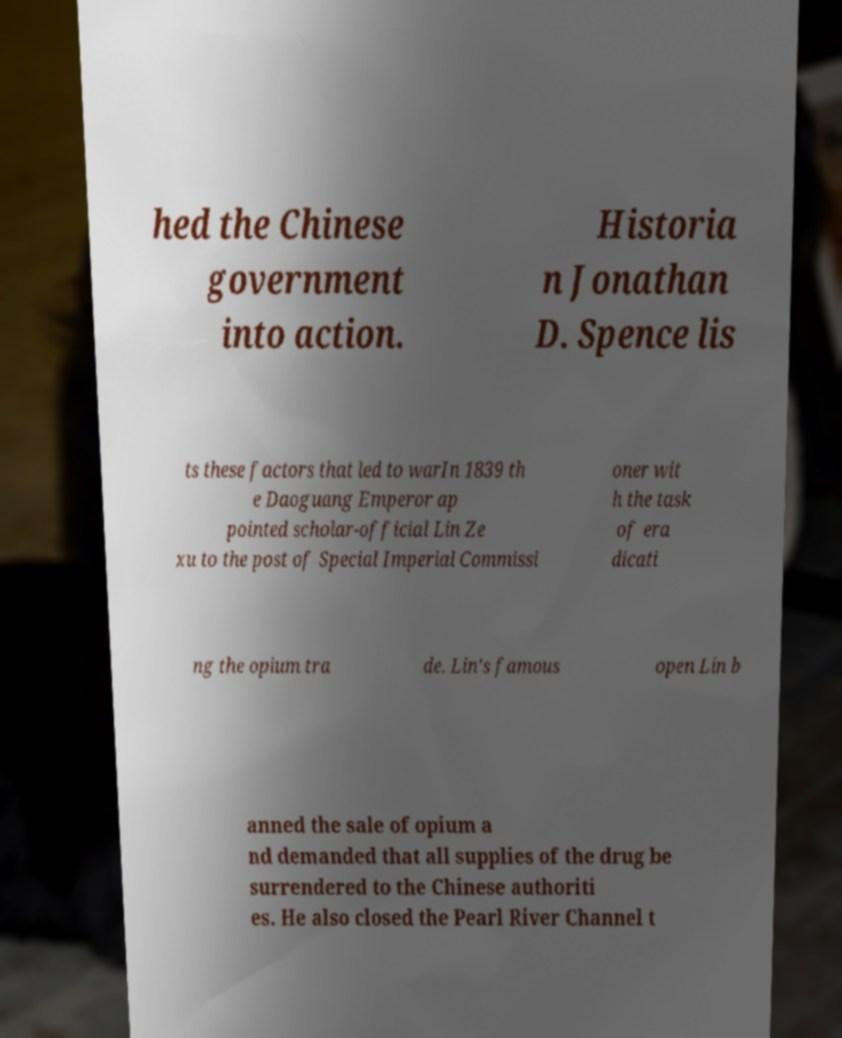What messages or text are displayed in this image? I need them in a readable, typed format. hed the Chinese government into action. Historia n Jonathan D. Spence lis ts these factors that led to warIn 1839 th e Daoguang Emperor ap pointed scholar-official Lin Ze xu to the post of Special Imperial Commissi oner wit h the task of era dicati ng the opium tra de. Lin's famous open Lin b anned the sale of opium a nd demanded that all supplies of the drug be surrendered to the Chinese authoriti es. He also closed the Pearl River Channel t 